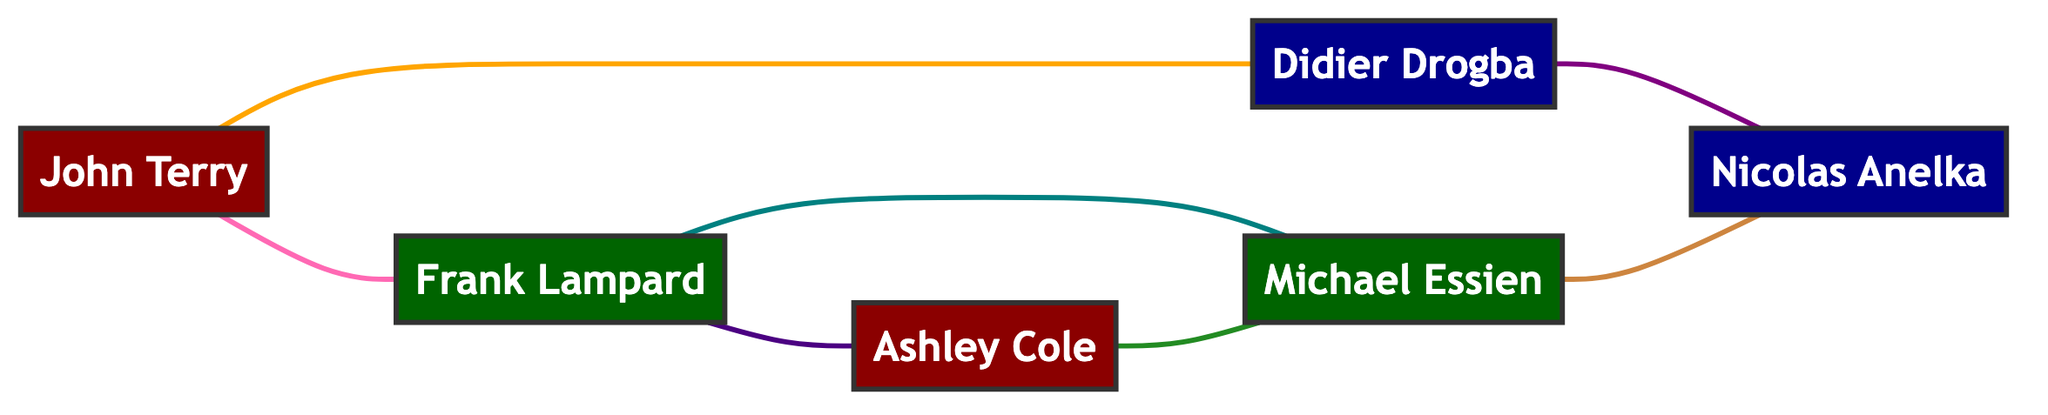What positions do the players in the graph represent? The graph includes players from three positions: Defenders (John Terry, Ashley Cole), Midfielders (Frank Lampard, Michael Essien), and Attackers (Didier Drogba, Nicolas Anelka). This information can be identified by examining the nodes and their associated position labels.
Answer: Defender, Midfielder, Attacker How many total players are in the diagram? By counting the nodes listed in the data, we find there are six players represented: John Terry, Frank Lampard, Didier Drogba, Ashley Cole, Michael Essien, and Nicolas Anelka.
Answer: 6 What type of relationship exists between Frank Lampard and Michael Essien? In the graph, Frank Lampard and Michael Essien share a relationship labeled "Shared Interests." This can be determined by looking at the edge connecting these two nodes and its associated relationship description.
Answer: Shared Interests Which player has the most connections in the diagram? To determine which player has the most connections, we will count the edges (relationships) connected to each player. Frank Lampard connects with three players (John Terry, Ashley Cole, Michael Essien), while the others have two or fewer. Therefore, Frank Lampard has the most connections.
Answer: Frank Lampard Between which two players is there a "Mutual Respect" relationship? By examining the edges, we find that the connection labeled "Mutual Respect" exists between Didier Drogba and Nicolas Anelka. This relationship can be identified by scanning through the edge list for the specific label.
Answer: Didier Drogba, Nicolas Anelka What is the total number of relationships represented in the graph? By counting all the edges listed in the data, we find that there are seven relationships present in the diagram, as each edge denotes one relationship between two players.
Answer: 7 Which two positions are directly connected through a "Community Projects" relationship? The "Community Projects" relationship connects Ashley Cole (Defender) and Michael Essien (Midfielder). This can be established by identifying the specific edge labeled "Community Projects" and noting the positions of the players it connects.
Answer: Defender, Midfielder Are there any relationships among players of the same position? Yes, the graph illustrates relationships among players of the same position: John Terry and Ashley Cole (Defenders) are connected, and Frank Lampard and Michael Essien (Midfielders) are also connected. This is evident by examining the edges connecting players of the same position.
Answer: Yes 